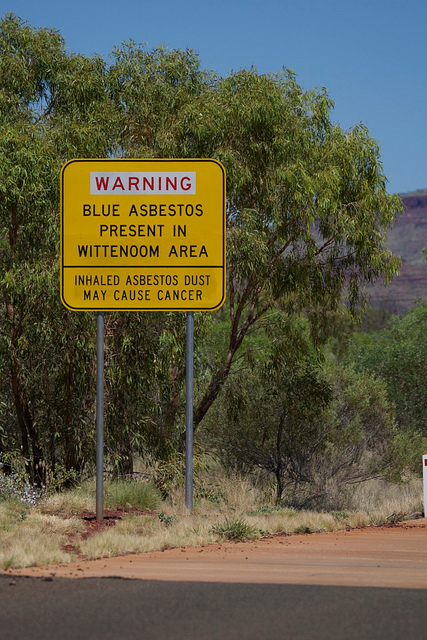Read all the text in this image. WARNING BLUE ASBESTOS PRESENT WITTENOOM M A Y CAUSE CANCER DUST ASBESTOS INHALED AREA IN 